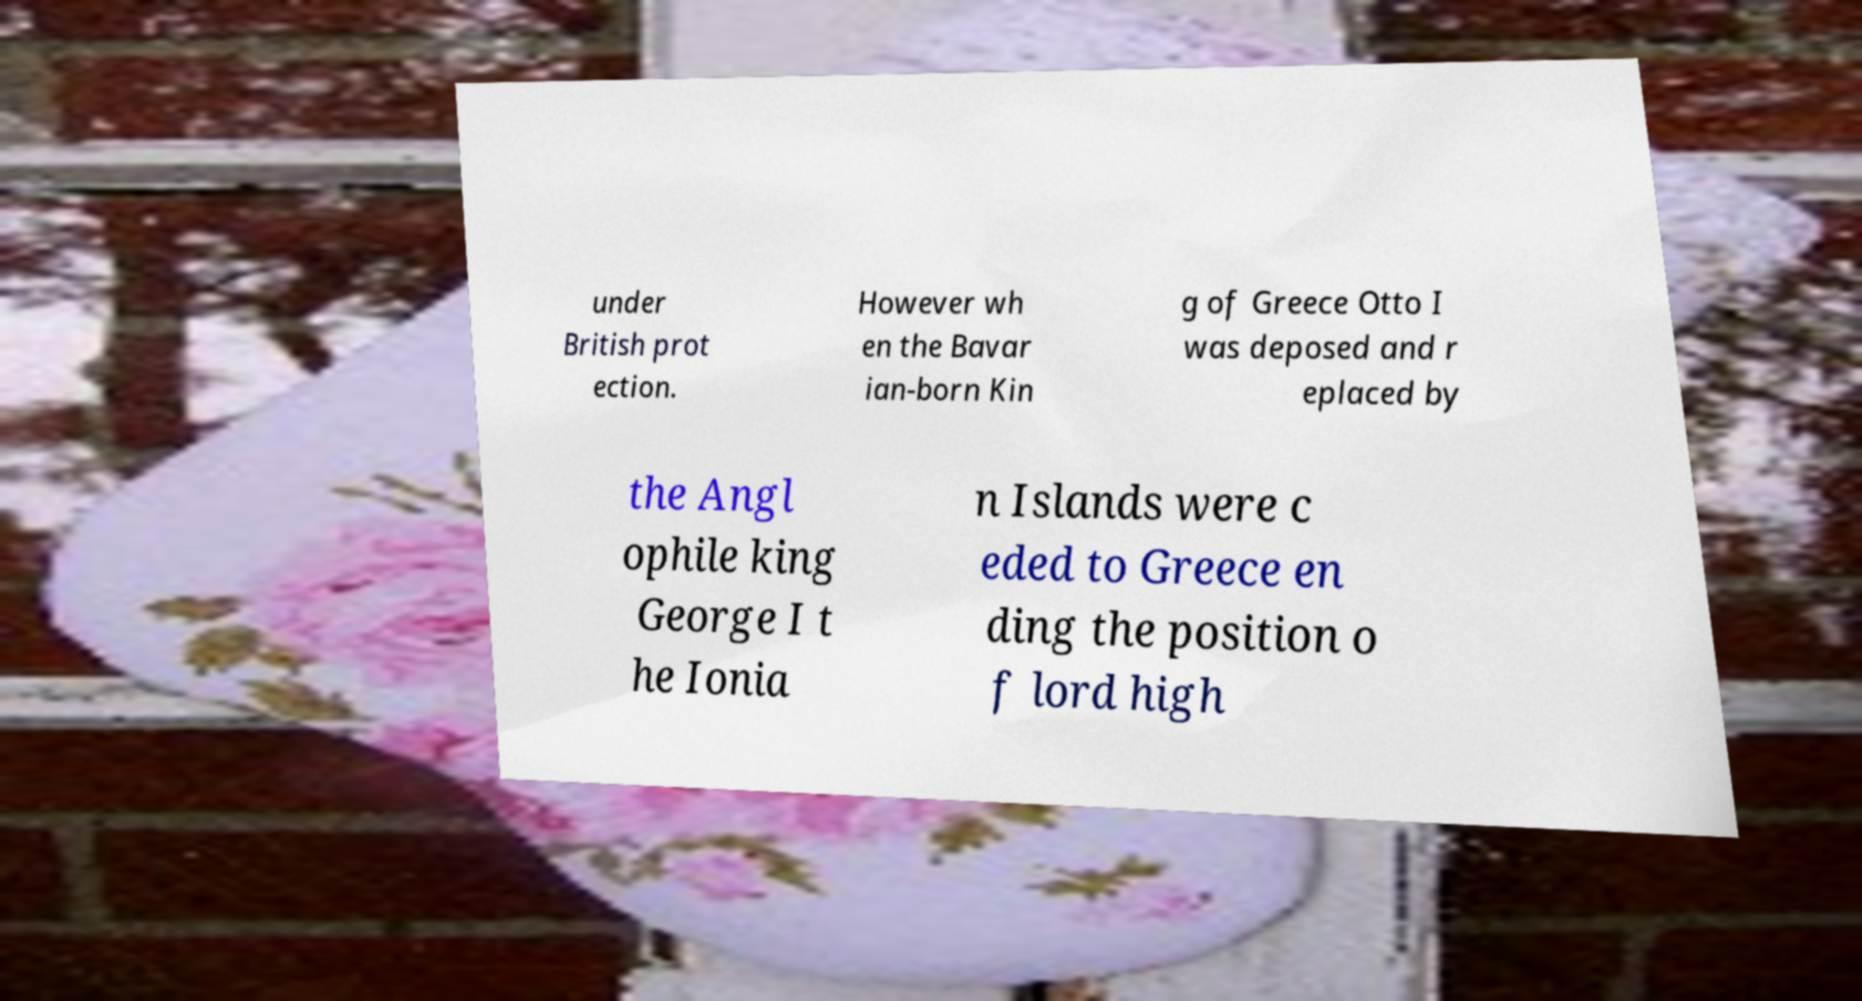What messages or text are displayed in this image? I need them in a readable, typed format. under British prot ection. However wh en the Bavar ian-born Kin g of Greece Otto I was deposed and r eplaced by the Angl ophile king George I t he Ionia n Islands were c eded to Greece en ding the position o f lord high 